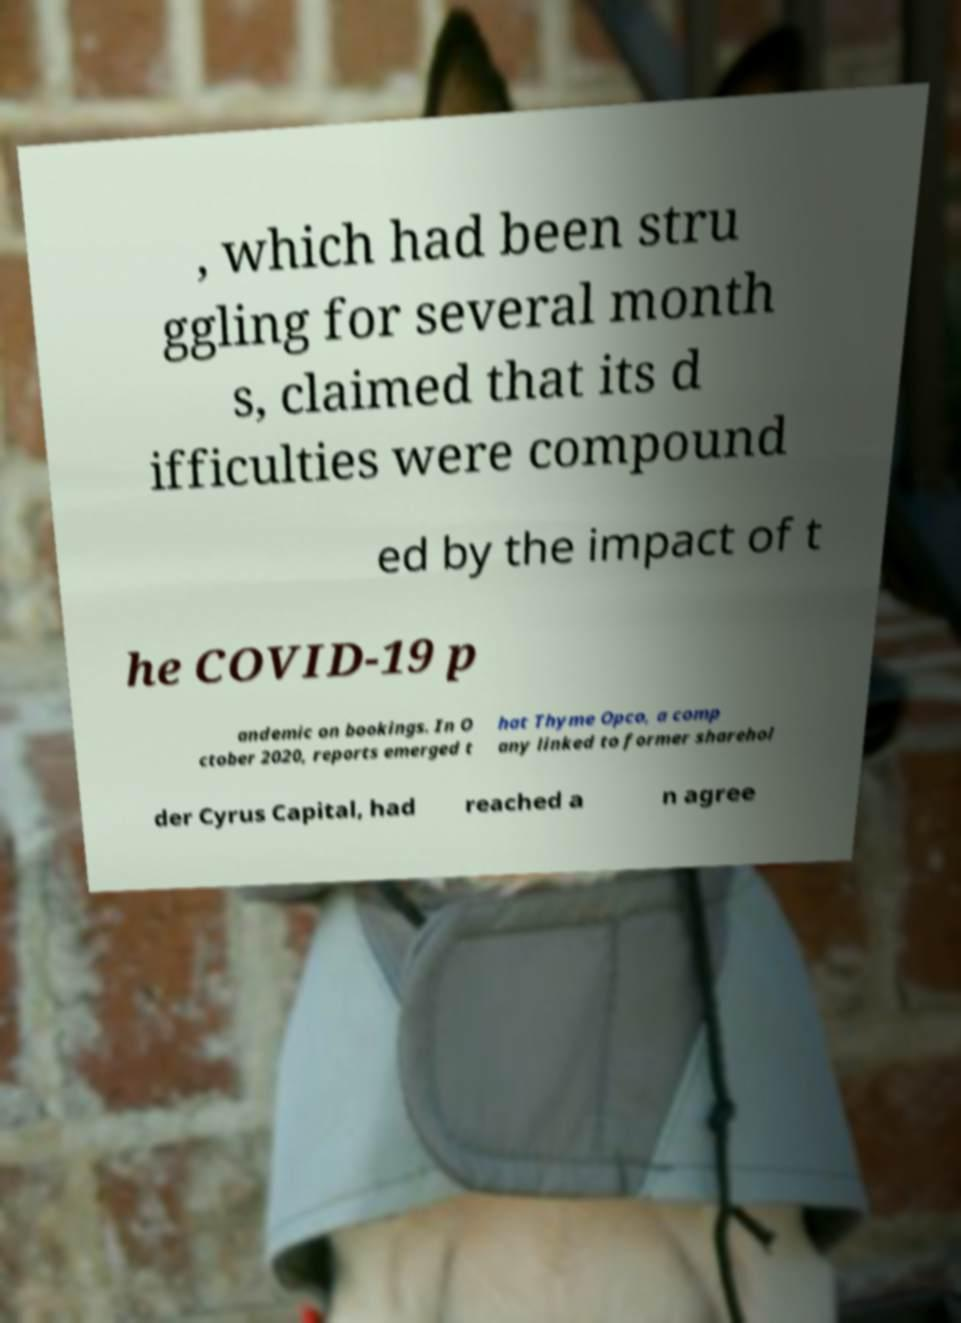For documentation purposes, I need the text within this image transcribed. Could you provide that? , which had been stru ggling for several month s, claimed that its d ifficulties were compound ed by the impact of t he COVID-19 p andemic on bookings. In O ctober 2020, reports emerged t hat Thyme Opco, a comp any linked to former sharehol der Cyrus Capital, had reached a n agree 